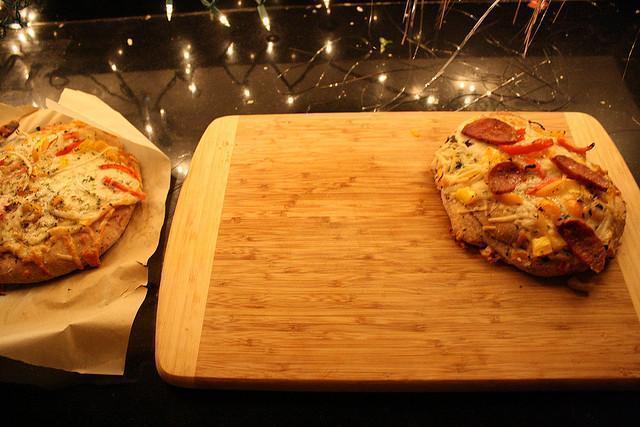How many dining tables are visible?
Give a very brief answer. 2. How many pizzas are in the picture?
Give a very brief answer. 2. 